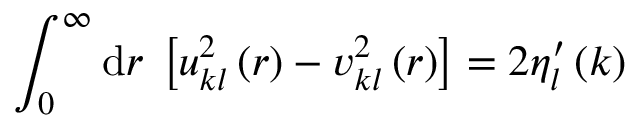Convert formula to latex. <formula><loc_0><loc_0><loc_500><loc_500>\int _ { 0 } ^ { \infty } d r \, \left [ u _ { k l } ^ { 2 } \left ( r \right ) - v _ { k l } ^ { 2 } \left ( r \right ) \right ] = 2 \eta _ { l } ^ { \prime } \left ( k \right )</formula> 